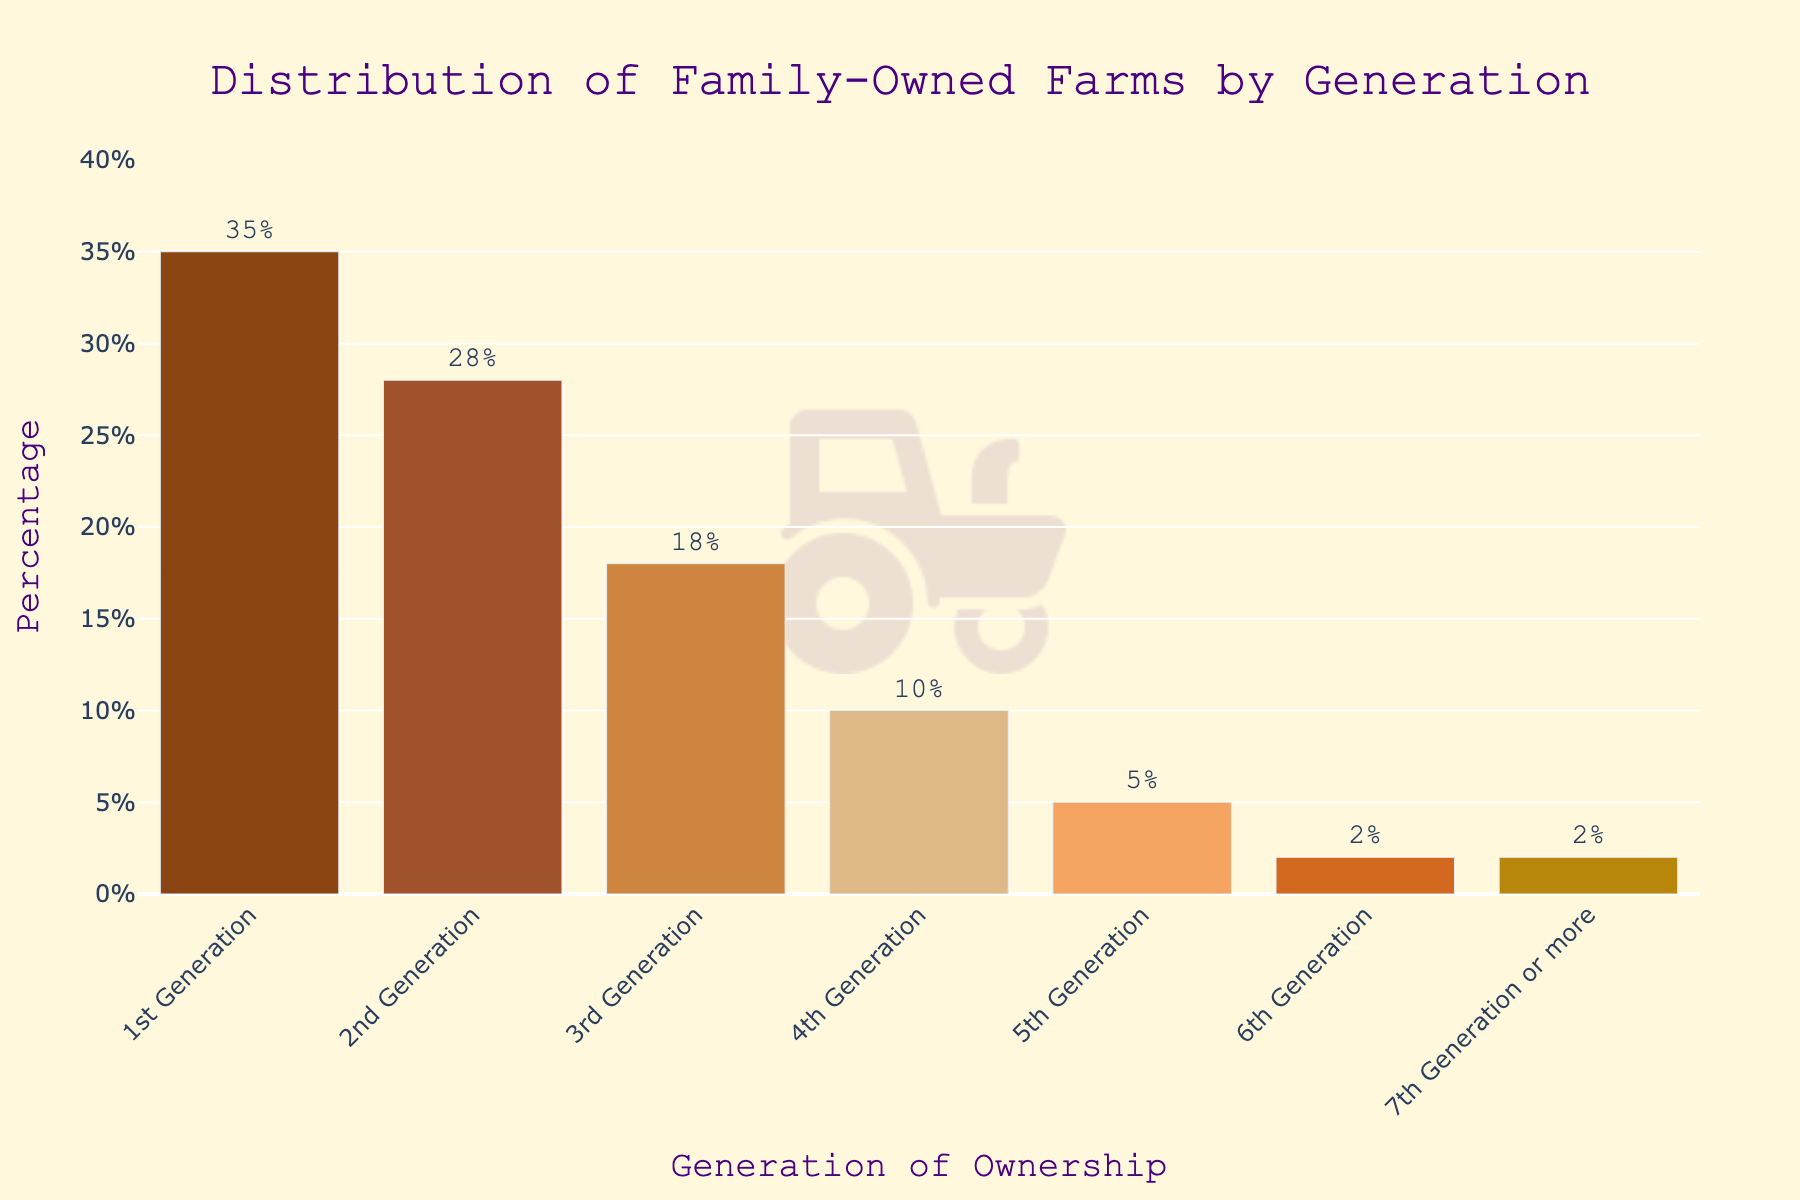What percentage of family farms is in their 3rd generation of ownership? Look at the bar labeled "3rd Generation" and read the percentage value.
Answer: 18% Among the generations listed, which has the highest percentage of ownership? Identify the tallest bar in the chart. It represents the "1st Generation" with a percentage of 35%.
Answer: 1st Generation By how much does the percentage of 2nd Generation farms exceed that of 4th Generation farms? Find the bars for "2nd Generation" and "4th Generation" and subtract the percentage of the latter from the former (28% - 10%).
Answer: 18% What is the combined percentage of farms that are in their 5th Generation or older? Sum the percentages of "5th Generation", "6th Generation", and "7th Generation or more" (5% + 2% + 2%).
Answer: 9% How does the percentage of 1st Generation farms compare to that of 2nd Generation farms? Check the heights of the bars for "1st Generation" (35%) and "2nd Generation" (28%). The 1st Generation bar is taller.
Answer: Greater Which generation has a percentage equal to that of the "6th Generation"? Identify another bar with the same height as the "6th Generation" bar (2%). This is the "7th Generation or more" bar.
Answer: 7th Generation or more Calculate the average percentage of farms from 3rd Generation to 5th Generation. Add the percentages for "3rd Generation", "4th Generation", and "5th Generation" (18% + 10% + 5%) and divide by 3.
Answer: 11% Which generation has the smallest percentage of ownership, and what is it? Look for the shortest bars in the chart for the smallest percentage value. Both "6th Generation" and "7th Generation or more" have the smallest percentages at 2%.
Answer: 6th Generation and 7th Generation or more How much higher is the percentage of 1st Generation farms compared to the sum of 4th and 5th Generation farms? Add the percentages for "4th Generation" and "5th Generation" (10% + 5%) and then subtract the sum from the percentage of "1st Generation" (35% - 15%).
Answer: 20% What's the percentage difference between the 3rd Generation and the average of the 2nd and 4th Generations? Calculate the average of "2nd Generation" and "4th Generation" ((28% + 10%) / 2 = 19%). Then, subtract the "3rd Generation" percentage from this average (19% - 18%).
Answer: 1% 